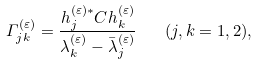<formula> <loc_0><loc_0><loc_500><loc_500>\varGamma _ { j k } ^ { ( \varepsilon ) } = \frac { h _ { j } ^ { ( \varepsilon ) * } C h _ { k } ^ { ( \varepsilon ) } } { \lambda _ { k } ^ { ( \varepsilon ) } - \bar { \lambda } _ { j } ^ { ( \varepsilon ) } } \quad ( j , k = 1 , 2 ) ,</formula> 